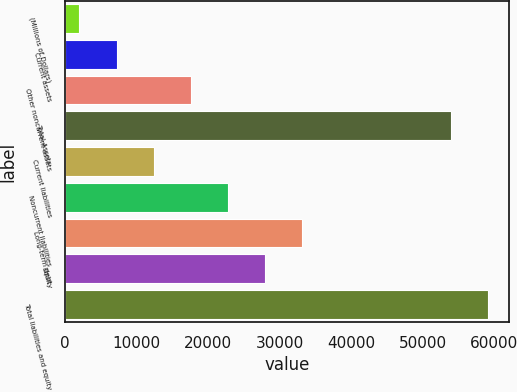<chart> <loc_0><loc_0><loc_500><loc_500><bar_chart><fcel>(Millions of Dollars)<fcel>Current assets<fcel>Other noncurrent assets<fcel>Total Assets<fcel>Current liabilities<fcel>Noncurrent liabilities<fcel>Long-term debt<fcel>Equity<fcel>Total liabilities and equity<nl><fcel>2018<fcel>7208.2<fcel>17588.6<fcel>53920<fcel>12398.4<fcel>22778.8<fcel>33159.2<fcel>27969<fcel>59110.2<nl></chart> 